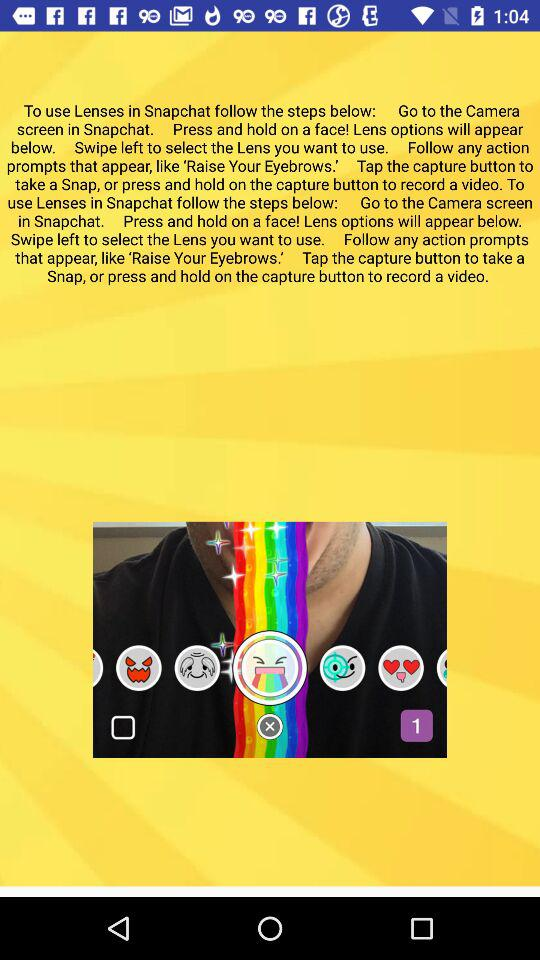How many lenses are there to choose from?
Answer the question using a single word or phrase. 6 